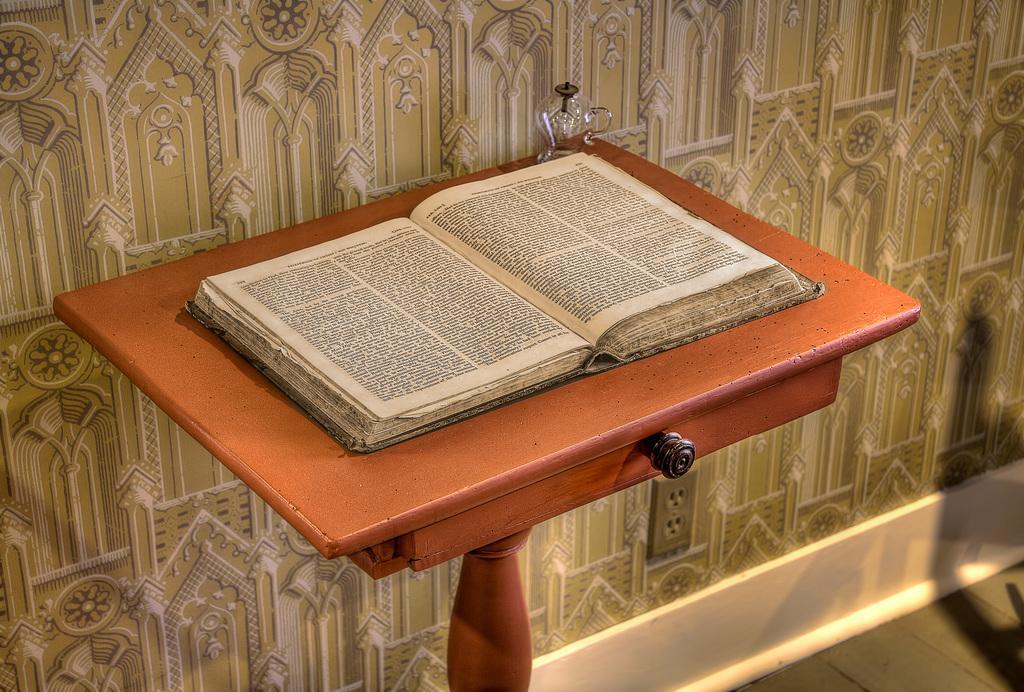In one or two sentences, can you explain what this image depicts? In the picture I can see a book opened is kept on the wooden table. In the background, I can see some pattern on the wall and I can see a socket is fixed to the wall. 